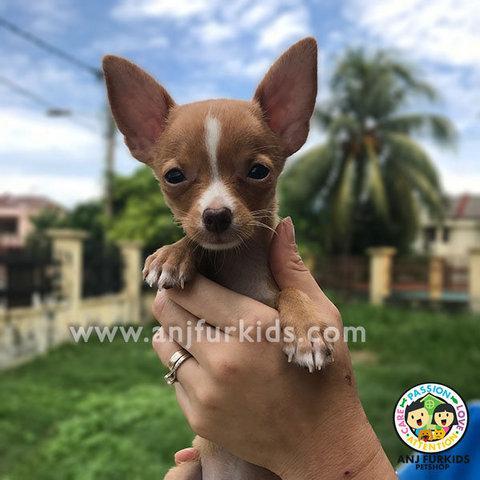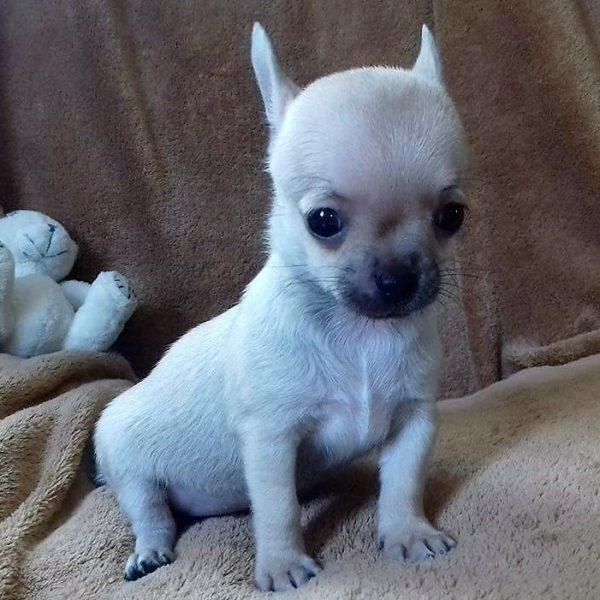The first image is the image on the left, the second image is the image on the right. Analyze the images presented: Is the assertion "There are no more than three dogs" valid? Answer yes or no. Yes. The first image is the image on the left, the second image is the image on the right. Considering the images on both sides, is "Dogs in at least one image are dressed in clothing." valid? Answer yes or no. No. 